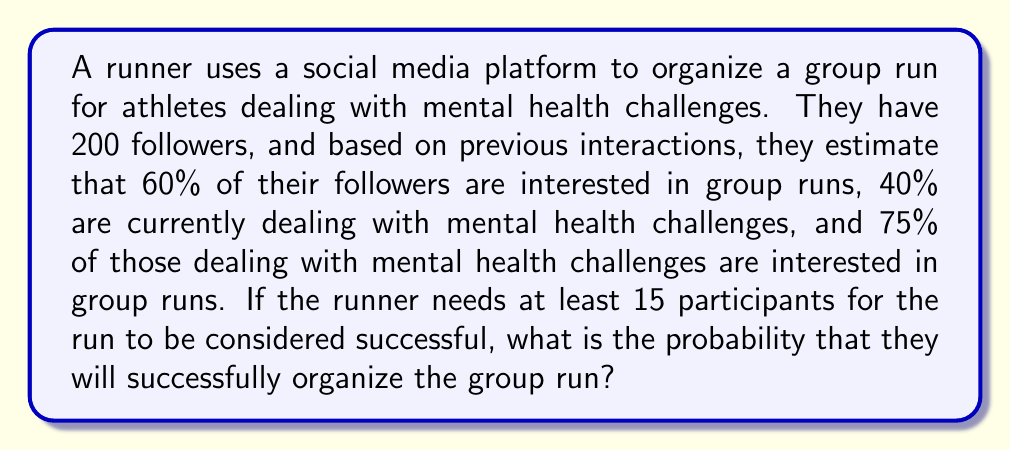Teach me how to tackle this problem. Let's break this down step-by-step:

1) First, we need to calculate the number of followers who are likely to participate. There are two groups we need to consider:

   a) Those interested in group runs but not dealing with mental health challenges
   b) Those dealing with mental health challenges and interested in group runs

2) Let's calculate each group:

   a) Followers not dealing with mental health challenges: $200 \times (1 - 0.4) = 120$
      Of these, 60% are interested in group runs: $120 \times 0.6 = 72$

   b) Followers dealing with mental health challenges: $200 \times 0.4 = 80$
      Of these, 75% are interested in group runs: $80 \times 0.75 = 60$

3) Total number of followers likely to participate: $72 + 60 = 132$

4) Now, we need to calculate the probability of at least 15 people participating. This is equivalent to the probability of not having 14 or fewer people participate.

5) We can model this as a binomial distribution, where each follower has a $\frac{132}{200} = 0.66$ probability of participating.

6) The probability of successfully organizing the run is:

   $$P(X \geq 15) = 1 - P(X \leq 14)$$

   Where $X$ is the number of participants, and $X \sim B(200, 0.66)$

7) Using the cumulative binomial probability function:

   $$P(X \geq 15) = 1 - \sum_{k=0}^{14} \binom{200}{k} (0.66)^k (1-0.66)^{200-k}$$

8) This calculation is complex to do by hand, so we would typically use statistical software or a calculator with this function.
Answer: Using a statistical calculator or software, we find:

$P(X \geq 15) \approx 0.9999999999999999$

The probability of successfully organizing the group run (getting at least 15 participants) is essentially 1 or 100%. 